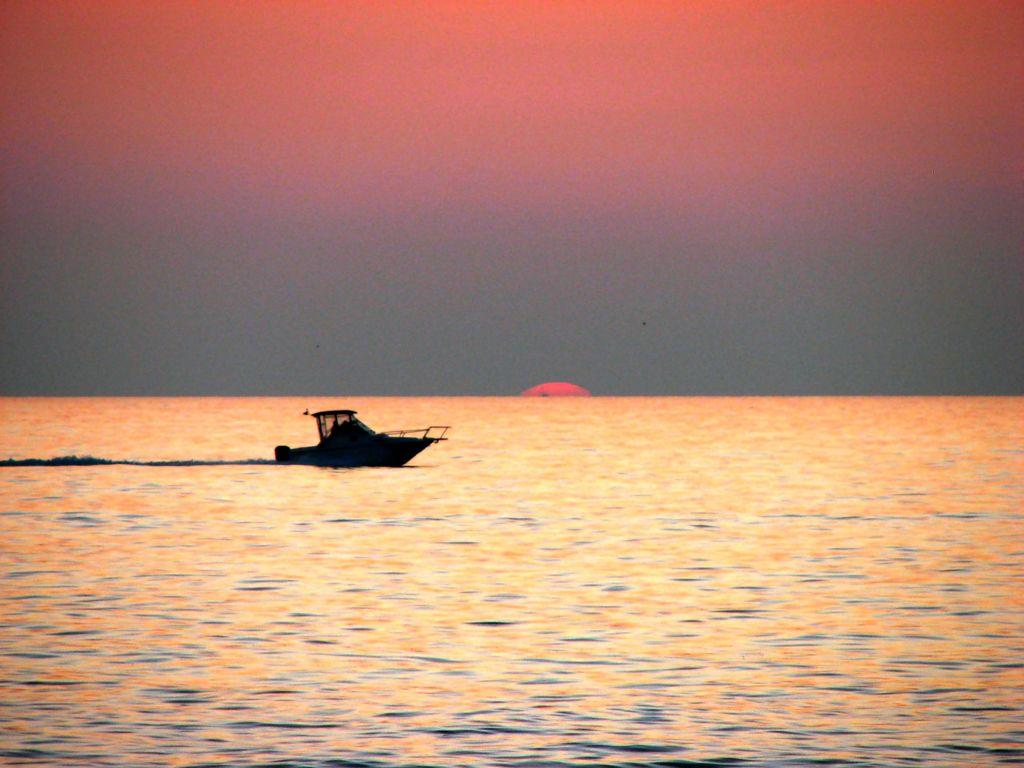What is the main subject of the image? The main subject of the image is a boat. Where is the boat located? The boat is on the water. What can be seen in the background of the image? The sun is visible in the sky in the background of the image. What type of bushes can be seen in the image? There are no bushes present in the image; it features a boat on the water with the sun visible in the sky. 